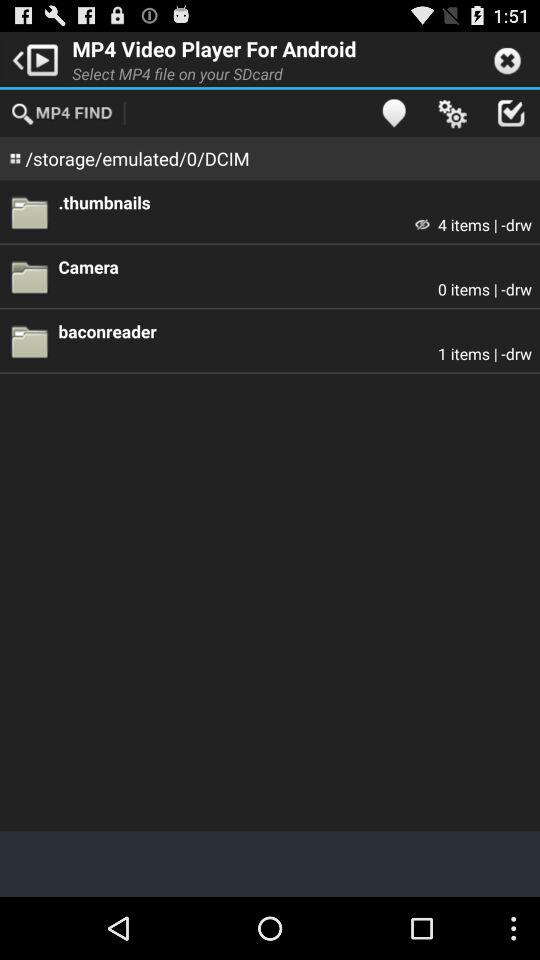How many items are in a baconreader file? There is 1 item in a baconreader file. 